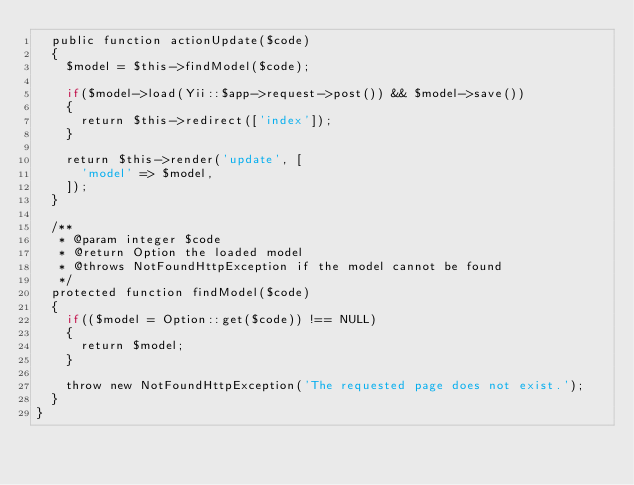<code> <loc_0><loc_0><loc_500><loc_500><_PHP_>	public function actionUpdate($code)
	{
		$model = $this->findModel($code);

		if($model->load(Yii::$app->request->post()) && $model->save())
		{
			return $this->redirect(['index']);
		}

		return $this->render('update', [
			'model' => $model,
		]);
	}

	/**
	 * @param integer $code
	 * @return Option the loaded model
	 * @throws NotFoundHttpException if the model cannot be found
	 */
	protected function findModel($code)
	{
		if(($model = Option::get($code)) !== NULL)
		{
			return $model;
		}

		throw new NotFoundHttpException('The requested page does not exist.');
	}
}
</code> 